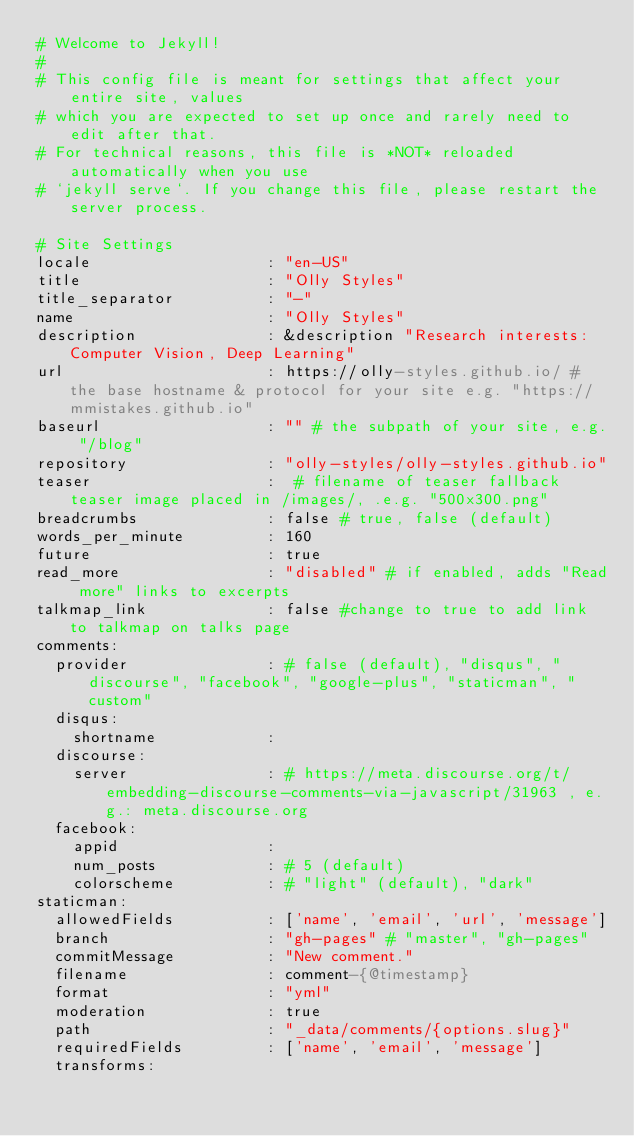Convert code to text. <code><loc_0><loc_0><loc_500><loc_500><_YAML_># Welcome to Jekyll!
#
# This config file is meant for settings that affect your entire site, values
# which you are expected to set up once and rarely need to edit after that.
# For technical reasons, this file is *NOT* reloaded automatically when you use
# `jekyll serve`. If you change this file, please restart the server process.

# Site Settings
locale                   : "en-US"
title                    : "Olly Styles"
title_separator          : "-"
name                     : "Olly Styles"
description              : &description "Research interests:  Computer Vision, Deep Learning"
url                      : https://olly-styles.github.io/ # the base hostname & protocol for your site e.g. "https://mmistakes.github.io"
baseurl                  : "" # the subpath of your site, e.g. "/blog"
repository               : "olly-styles/olly-styles.github.io"
teaser                   :  # filename of teaser fallback teaser image placed in /images/, .e.g. "500x300.png"
breadcrumbs              : false # true, false (default)
words_per_minute         : 160
future                   : true
read_more                : "disabled" # if enabled, adds "Read more" links to excerpts
talkmap_link             : false #change to true to add link to talkmap on talks page
comments:
  provider               : # false (default), "disqus", "discourse", "facebook", "google-plus", "staticman", "custom"
  disqus:
    shortname            :
  discourse:
    server               : # https://meta.discourse.org/t/embedding-discourse-comments-via-javascript/31963 , e.g.: meta.discourse.org
  facebook:
    appid                :
    num_posts            : # 5 (default)
    colorscheme          : # "light" (default), "dark"
staticman:
  allowedFields          : ['name', 'email', 'url', 'message']
  branch                 : "gh-pages" # "master", "gh-pages"
  commitMessage          : "New comment."
  filename               : comment-{@timestamp}
  format                 : "yml"
  moderation             : true
  path                   : "_data/comments/{options.slug}"
  requiredFields         : ['name', 'email', 'message']
  transforms:</code> 